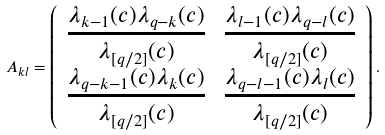Convert formula to latex. <formula><loc_0><loc_0><loc_500><loc_500>A _ { k l } = \left ( \begin{array} { c c } \frac { \lambda _ { k - 1 } ( c ) \lambda _ { q - k } ( c ) } { \lambda _ { [ q / 2 ] } ( c ) } & \frac { \lambda _ { l - 1 } ( c ) \lambda _ { q - l } ( c ) } { \lambda _ { [ q / 2 ] } ( c ) } \\ \frac { \lambda _ { q - k - 1 } ( c ) \lambda _ { k } ( c ) } { \lambda _ { [ q / 2 ] } ( c ) } & \frac { \lambda _ { q - l - 1 } ( c ) \lambda _ { l } ( c ) } { \lambda _ { [ q / 2 ] } ( c ) } \end{array} \right ) .</formula> 